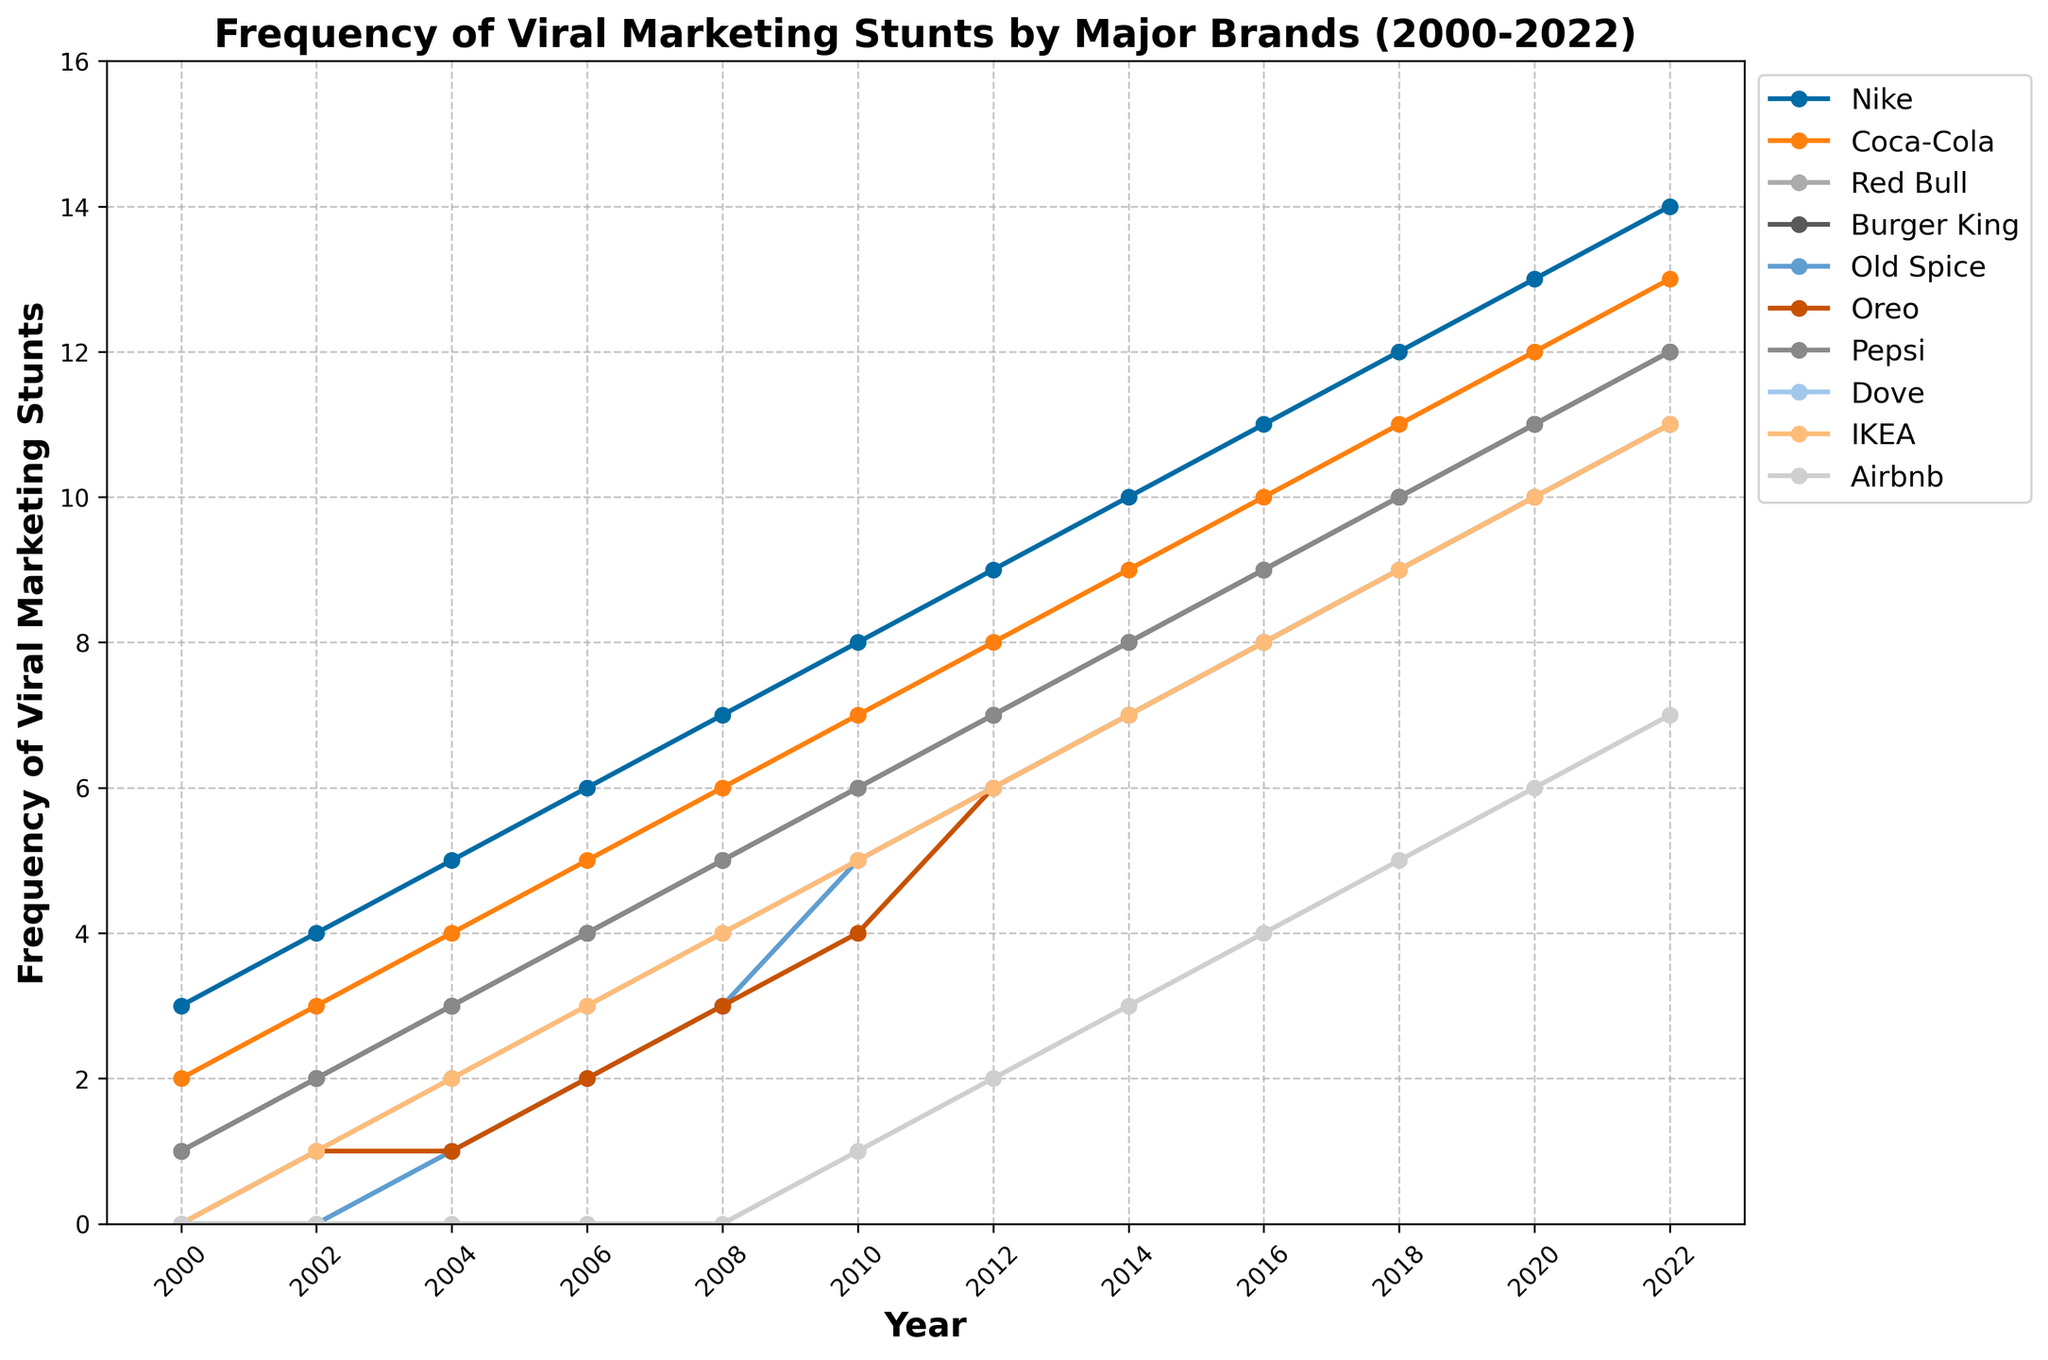How many more viral marketing stunts did Nike conduct in 2022 compared to 2000? To find this, subtract the number of stunts in 2000 from the number of stunts in 2022 for Nike. In 2022, Nike conducted 14 stunts, and in 2000, they conducted 3. So, 14 - 3 = 11.
Answer: 11 Which brand saw the highest increase in the number of viral marketing stunts between 2000 and 2022? To determine the highest increase, calculate the difference between the 2022 and 2000 values for each brand. Nike went from 3 to 14 (+11), Coca-Cola from 2 to 13 (+11), Red Bull from 1 to 12 (+11), Burger King from 1 to 12 (+11), Old Spice from 0 to 11 (+11), Oreo from 0 to 11 (+11), Pepsi from 1 to 12 (+11), Dove from 0 to 11 (+11), IKEA from 0 to 11 (+11), Airbnb from 0 to 7 (+7). Several brands (Nike, Coca-Cola, Red Bull, Burger King, Old Spice, Oreo, Pepsi, Dove, and IKEA) saw an increase of 11.
Answer: Multiple (Nike, Coca-Cola, Red Bull, Burger King, Old Spice, Oreo, Pepsi, Dove, IKEA) In which year did Coca-Cola and Oreo both have the same frequency of viral marketing stunts? Look for the year where the values for Coca-Cola and Oreo in the chart are equal. For 2022, Coca-Cola had 13 stunts, and Oreo had 11 stunts. Go back year by year comparing until you find a match, which happens in the year 2008 when both had 6 stunts.
Answer: 2008 What is the trend in the frequency of viral marketing stunts for Dove from 2000 to 2022? By observing the line for Dove from 2000 to 2022, it starts with 0 stunts in 2000 and increases steadily to 11 stunts by 2022. The trend is a consistent upward trend.
Answer: Upward trend Which brand conducted the fewest viral marketing stunts in 2010? Check the 2010 data for all brands: Nike (8), Coca-Cola (7), Red Bull (6), Burger King (6), Old Spice (5), Oreo (4), Pepsi (6), Dove (5), IKEA (5), Airbnb (1). Airbnb conducted the fewest stunts.
Answer: Airbnb Calculate the average frequency of viral marketing stunts for Pepsi from 2000 to 2022. First, sum the total number of stunts for Pepsi over all years: 1+2+3+4+5+6+7+8+9+10+11+12 = 78. Then, divide by the number of years (12). So, the average is 78 / 12 = 6.5.
Answer: 6.5 How many times did Red Bull conduct more stunts than Old Spice from 2000 to 2022? Compare the data for each year to see if Red Bull's value is higher than Old Spice's value. Reviewing the years: 2000 (1 > 0), 2002 (2 > 0), 2004 (3 > 1), 2006 (4 > 2), 2008 (5 > 3), 2010 (6 > 5), 2012 (7 > 6), 2014 (8 > 7), 2016 (9 > 8), 2018 (10 > 9), 2020 (11 > 10), 2022 (12 > 11). Red Bull conducted more stunts every year, so 12 times.
Answer: 12 What was the combined total of viral marketing stunts conducted by all brands in 2018? Sum the number of stunts for each brand in 2018: 12 (Nike) + 11 (Coca-Cola) + 10 (Red Bull) + 10 (Burger King) + 9 (Old Spice) + 9 (Oreo) + 10 (Pepsi) + 9 (Dove) + 9 (IKEA) + 5 (Airbnb) = 94.
Answer: 94 